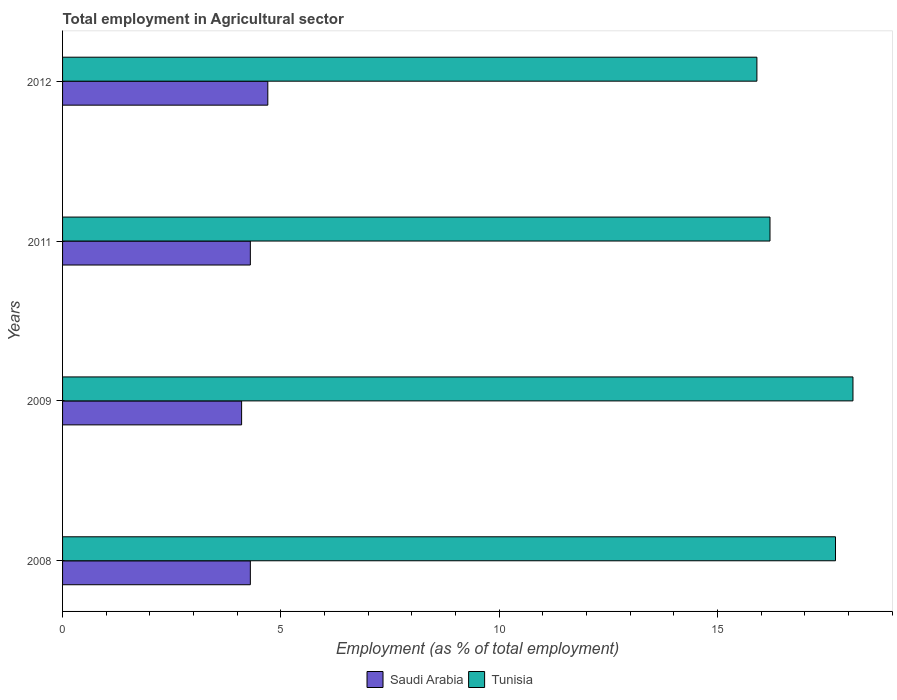How many different coloured bars are there?
Your response must be concise. 2. How many bars are there on the 4th tick from the bottom?
Keep it short and to the point. 2. What is the employment in agricultural sector in Tunisia in 2008?
Give a very brief answer. 17.7. Across all years, what is the maximum employment in agricultural sector in Tunisia?
Your answer should be very brief. 18.1. Across all years, what is the minimum employment in agricultural sector in Saudi Arabia?
Keep it short and to the point. 4.1. In which year was the employment in agricultural sector in Saudi Arabia maximum?
Ensure brevity in your answer.  2012. What is the total employment in agricultural sector in Tunisia in the graph?
Give a very brief answer. 67.9. What is the difference between the employment in agricultural sector in Saudi Arabia in 2008 and that in 2011?
Offer a very short reply. 0. What is the difference between the employment in agricultural sector in Tunisia in 2011 and the employment in agricultural sector in Saudi Arabia in 2008?
Offer a terse response. 11.9. What is the average employment in agricultural sector in Tunisia per year?
Keep it short and to the point. 16.98. In the year 2012, what is the difference between the employment in agricultural sector in Tunisia and employment in agricultural sector in Saudi Arabia?
Keep it short and to the point. 11.2. In how many years, is the employment in agricultural sector in Tunisia greater than 16 %?
Ensure brevity in your answer.  3. What is the ratio of the employment in agricultural sector in Tunisia in 2009 to that in 2012?
Offer a terse response. 1.14. What is the difference between the highest and the second highest employment in agricultural sector in Tunisia?
Offer a very short reply. 0.4. What is the difference between the highest and the lowest employment in agricultural sector in Saudi Arabia?
Your response must be concise. 0.6. In how many years, is the employment in agricultural sector in Saudi Arabia greater than the average employment in agricultural sector in Saudi Arabia taken over all years?
Keep it short and to the point. 1. What does the 2nd bar from the top in 2008 represents?
Ensure brevity in your answer.  Saudi Arabia. What does the 1st bar from the bottom in 2009 represents?
Provide a succinct answer. Saudi Arabia. How many years are there in the graph?
Provide a succinct answer. 4. Does the graph contain any zero values?
Your response must be concise. No. Does the graph contain grids?
Offer a terse response. No. How are the legend labels stacked?
Provide a short and direct response. Horizontal. What is the title of the graph?
Keep it short and to the point. Total employment in Agricultural sector. Does "Sub-Saharan Africa (all income levels)" appear as one of the legend labels in the graph?
Offer a terse response. No. What is the label or title of the X-axis?
Keep it short and to the point. Employment (as % of total employment). What is the Employment (as % of total employment) of Saudi Arabia in 2008?
Provide a succinct answer. 4.3. What is the Employment (as % of total employment) of Tunisia in 2008?
Offer a terse response. 17.7. What is the Employment (as % of total employment) of Saudi Arabia in 2009?
Ensure brevity in your answer.  4.1. What is the Employment (as % of total employment) of Tunisia in 2009?
Your answer should be very brief. 18.1. What is the Employment (as % of total employment) of Saudi Arabia in 2011?
Give a very brief answer. 4.3. What is the Employment (as % of total employment) of Tunisia in 2011?
Provide a short and direct response. 16.2. What is the Employment (as % of total employment) of Saudi Arabia in 2012?
Your response must be concise. 4.7. What is the Employment (as % of total employment) of Tunisia in 2012?
Provide a succinct answer. 15.9. Across all years, what is the maximum Employment (as % of total employment) in Saudi Arabia?
Provide a short and direct response. 4.7. Across all years, what is the maximum Employment (as % of total employment) of Tunisia?
Your answer should be compact. 18.1. Across all years, what is the minimum Employment (as % of total employment) of Saudi Arabia?
Offer a very short reply. 4.1. Across all years, what is the minimum Employment (as % of total employment) of Tunisia?
Provide a short and direct response. 15.9. What is the total Employment (as % of total employment) of Saudi Arabia in the graph?
Your response must be concise. 17.4. What is the total Employment (as % of total employment) of Tunisia in the graph?
Offer a very short reply. 67.9. What is the difference between the Employment (as % of total employment) of Saudi Arabia in 2008 and that in 2009?
Your answer should be compact. 0.2. What is the difference between the Employment (as % of total employment) of Tunisia in 2008 and that in 2009?
Make the answer very short. -0.4. What is the difference between the Employment (as % of total employment) in Saudi Arabia in 2008 and that in 2011?
Ensure brevity in your answer.  0. What is the difference between the Employment (as % of total employment) in Tunisia in 2008 and that in 2011?
Give a very brief answer. 1.5. What is the difference between the Employment (as % of total employment) of Tunisia in 2008 and that in 2012?
Provide a short and direct response. 1.8. What is the difference between the Employment (as % of total employment) in Tunisia in 2009 and that in 2011?
Your response must be concise. 1.9. What is the difference between the Employment (as % of total employment) in Saudi Arabia in 2011 and that in 2012?
Offer a terse response. -0.4. What is the difference between the Employment (as % of total employment) of Tunisia in 2011 and that in 2012?
Offer a terse response. 0.3. What is the difference between the Employment (as % of total employment) of Saudi Arabia in 2011 and the Employment (as % of total employment) of Tunisia in 2012?
Your answer should be compact. -11.6. What is the average Employment (as % of total employment) in Saudi Arabia per year?
Offer a very short reply. 4.35. What is the average Employment (as % of total employment) in Tunisia per year?
Your answer should be very brief. 16.98. In the year 2009, what is the difference between the Employment (as % of total employment) of Saudi Arabia and Employment (as % of total employment) of Tunisia?
Your response must be concise. -14. In the year 2011, what is the difference between the Employment (as % of total employment) of Saudi Arabia and Employment (as % of total employment) of Tunisia?
Keep it short and to the point. -11.9. In the year 2012, what is the difference between the Employment (as % of total employment) of Saudi Arabia and Employment (as % of total employment) of Tunisia?
Provide a short and direct response. -11.2. What is the ratio of the Employment (as % of total employment) in Saudi Arabia in 2008 to that in 2009?
Your response must be concise. 1.05. What is the ratio of the Employment (as % of total employment) in Tunisia in 2008 to that in 2009?
Offer a very short reply. 0.98. What is the ratio of the Employment (as % of total employment) of Tunisia in 2008 to that in 2011?
Your answer should be very brief. 1.09. What is the ratio of the Employment (as % of total employment) in Saudi Arabia in 2008 to that in 2012?
Your answer should be compact. 0.91. What is the ratio of the Employment (as % of total employment) of Tunisia in 2008 to that in 2012?
Keep it short and to the point. 1.11. What is the ratio of the Employment (as % of total employment) of Saudi Arabia in 2009 to that in 2011?
Give a very brief answer. 0.95. What is the ratio of the Employment (as % of total employment) in Tunisia in 2009 to that in 2011?
Your answer should be very brief. 1.12. What is the ratio of the Employment (as % of total employment) of Saudi Arabia in 2009 to that in 2012?
Your answer should be very brief. 0.87. What is the ratio of the Employment (as % of total employment) in Tunisia in 2009 to that in 2012?
Your answer should be compact. 1.14. What is the ratio of the Employment (as % of total employment) in Saudi Arabia in 2011 to that in 2012?
Your answer should be very brief. 0.91. What is the ratio of the Employment (as % of total employment) of Tunisia in 2011 to that in 2012?
Offer a terse response. 1.02. What is the difference between the highest and the second highest Employment (as % of total employment) in Saudi Arabia?
Your answer should be very brief. 0.4. What is the difference between the highest and the lowest Employment (as % of total employment) in Tunisia?
Provide a succinct answer. 2.2. 